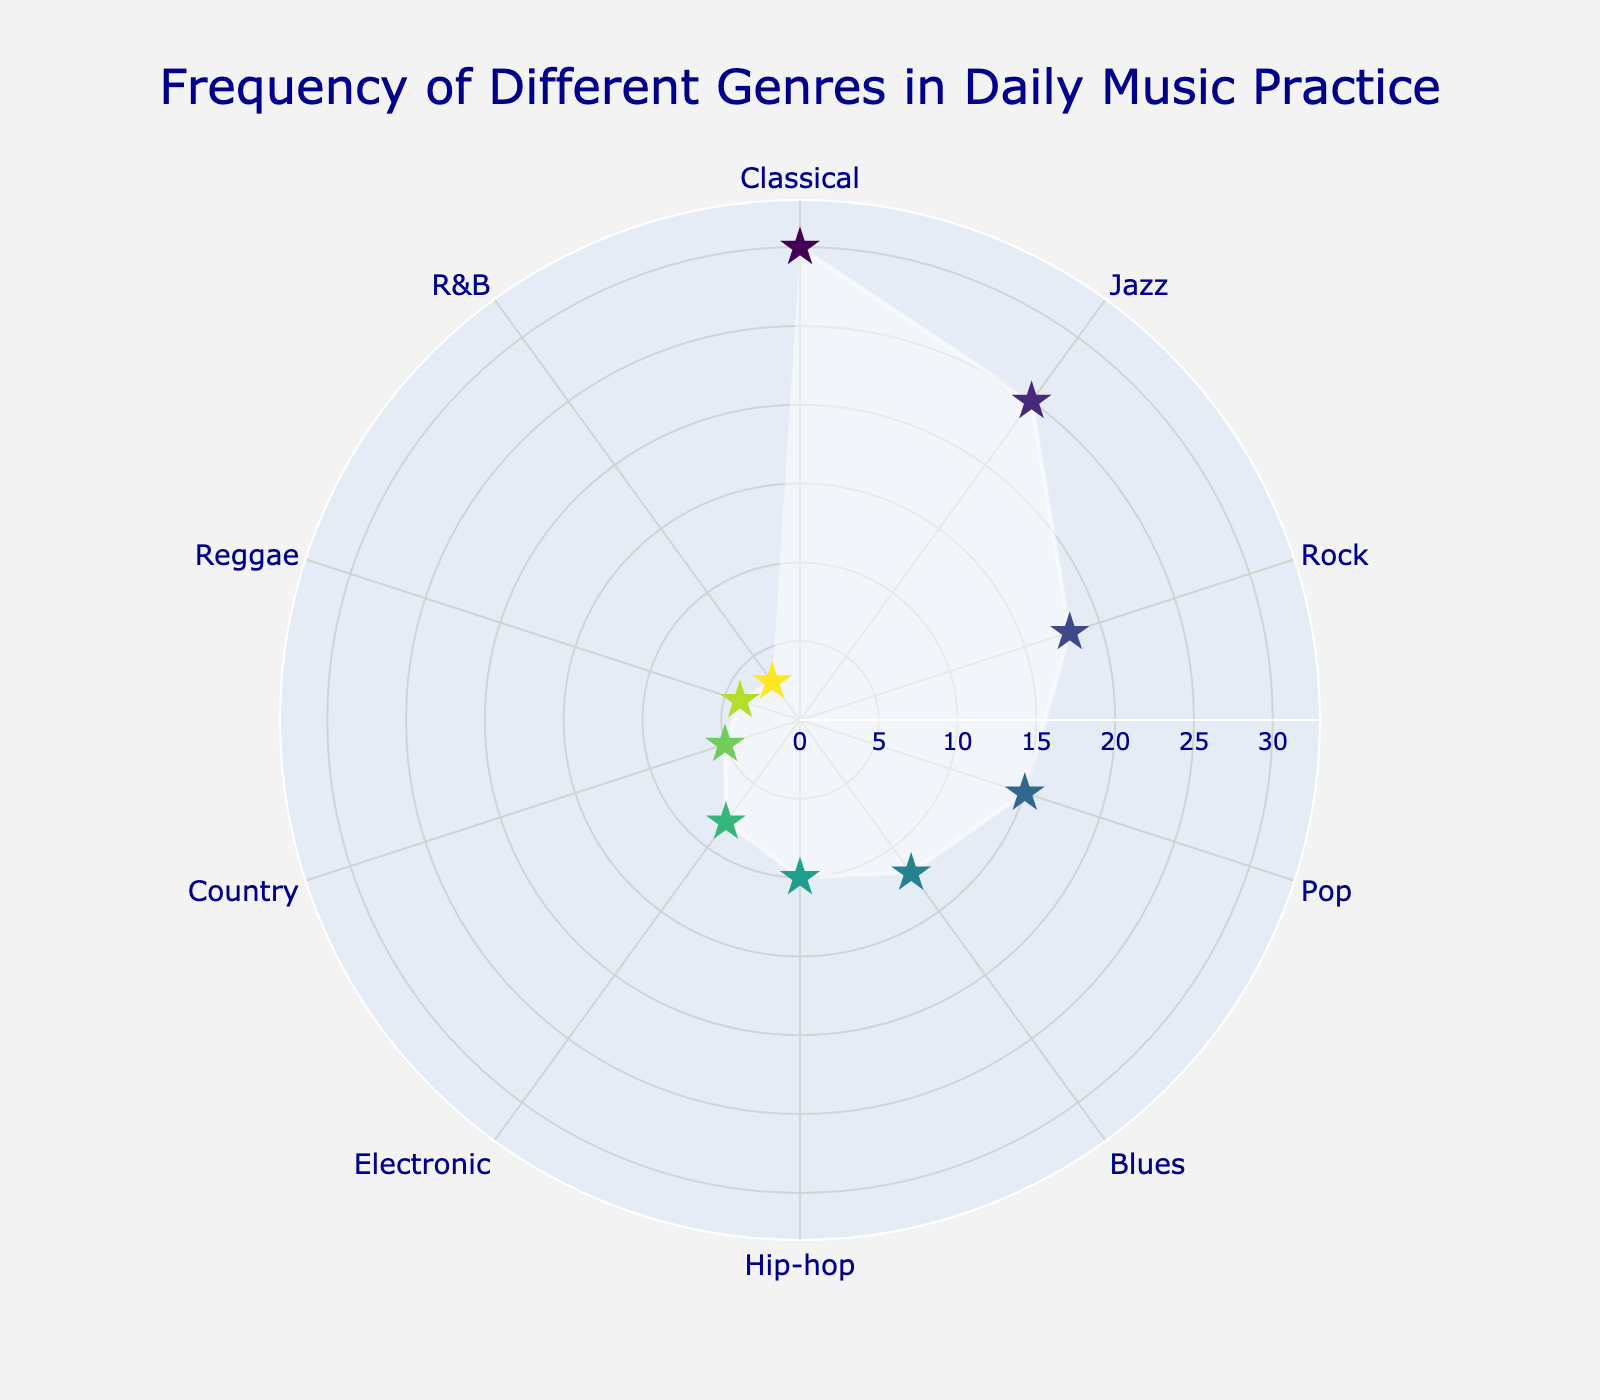What's the title of the figure? The title of the figure is displayed at the top center. It reads "Frequency of Different Genres in Daily Music Practice".
Answer: Frequency of Different Genres in Daily Music Practice How many different genres are displayed on the chart? Count the number of different labels around the polar chart. There are 10 different genres listed.
Answer: 10 Which genre has the highest frequency? Look for the label with the largest radius from the center of the chart. Classical has a frequency of 30, which is the highest.
Answer: Classical What genre appears at the 90-degree mark, and what is its frequency? The angular axis is set to rotate counter-clockwise starting from 90 degrees. Find the genre closest to this mark and check its frequency. Pop is displayed with a frequency of 15.
Answer: Pop, 15 What is the range value on the radial axis? Identify the maximum value indicated on the radial axis. The highest point on the axis is 33 (30*1.1).
Answer: [0, 33] How many genres have a frequency of 10 or more? Count the number of genres whose values are 10 or higher, as shown by the radial distance. There are 6 genres meeting the criteria (Classical, Jazz, Rock, Pop, Blues, Hip-hop).
Answer: 6 What is the sum of frequencies for Rock and Blues? Add the frequencies of Rock and Blues from the data points in the chart: 18 (Rock) + 12 (Blues) = 30.
Answer: 30 Which genre has the second lowest frequency and what is its value? Identify the genre with the second smallest radius from the center. Reggae has the second lowest frequency of 4.
Answer: Reggae, 4 Which genres have a frequency less than 10? List the genres with a radial value below 10: Electronic, Country, Reggae, R&B.
Answer: Electronic, Country, Reggae, R&B Comparing Jazz and Rock, which genre is practiced more and by how much? Compare the radial distance values of Jazz and Rock. Jazz has a frequency of 25, and Rock has a frequency of 18. The difference is 25 - 18 = 7.
Answer: Jazz, 7 